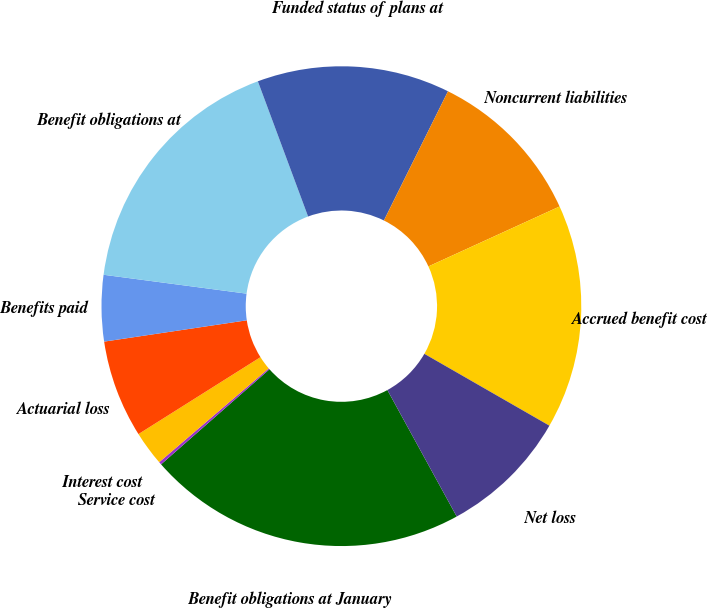Convert chart. <chart><loc_0><loc_0><loc_500><loc_500><pie_chart><fcel>Benefit obligations at January<fcel>Service cost<fcel>Interest cost<fcel>Actuarial loss<fcel>Benefits paid<fcel>Benefit obligations at<fcel>Funded status of plans at<fcel>Noncurrent liabilities<fcel>Accrued benefit cost<fcel>Net loss<nl><fcel>21.52%<fcel>0.19%<fcel>2.32%<fcel>6.59%<fcel>4.45%<fcel>17.25%<fcel>12.99%<fcel>10.85%<fcel>15.12%<fcel>8.72%<nl></chart> 